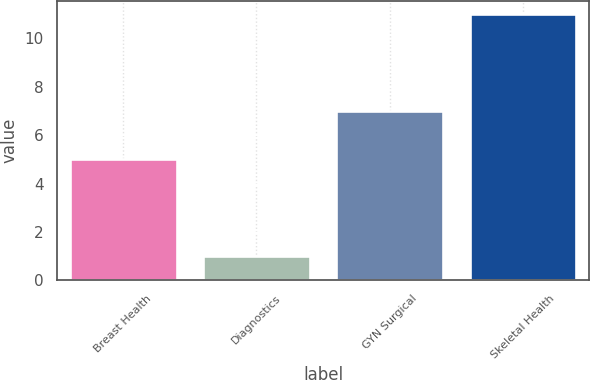Convert chart. <chart><loc_0><loc_0><loc_500><loc_500><bar_chart><fcel>Breast Health<fcel>Diagnostics<fcel>GYN Surgical<fcel>Skeletal Health<nl><fcel>5<fcel>1<fcel>7<fcel>11<nl></chart> 